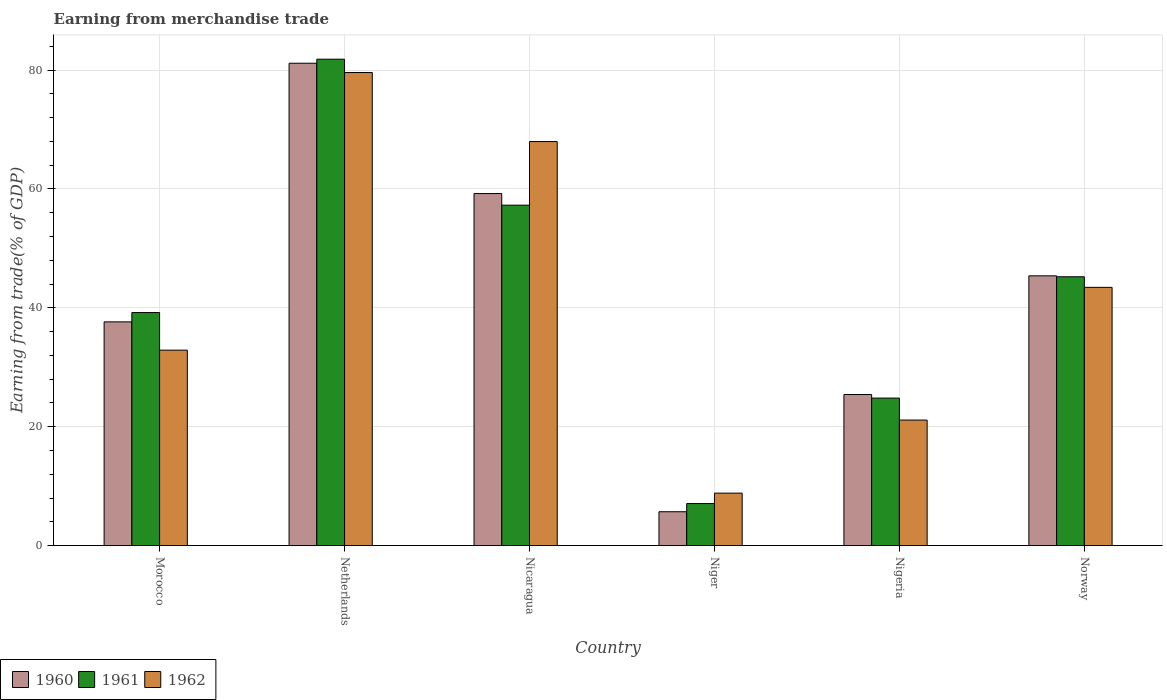How many different coloured bars are there?
Keep it short and to the point. 3. How many groups of bars are there?
Provide a succinct answer. 6. Are the number of bars per tick equal to the number of legend labels?
Provide a short and direct response. Yes. Are the number of bars on each tick of the X-axis equal?
Offer a very short reply. Yes. How many bars are there on the 2nd tick from the right?
Your response must be concise. 3. In how many cases, is the number of bars for a given country not equal to the number of legend labels?
Provide a succinct answer. 0. What is the earnings from trade in 1960 in Netherlands?
Offer a terse response. 81.16. Across all countries, what is the maximum earnings from trade in 1962?
Provide a short and direct response. 79.59. Across all countries, what is the minimum earnings from trade in 1960?
Your answer should be compact. 5.69. In which country was the earnings from trade in 1961 maximum?
Ensure brevity in your answer.  Netherlands. In which country was the earnings from trade in 1961 minimum?
Provide a succinct answer. Niger. What is the total earnings from trade in 1960 in the graph?
Keep it short and to the point. 254.51. What is the difference between the earnings from trade in 1960 in Netherlands and that in Nigeria?
Provide a short and direct response. 55.74. What is the difference between the earnings from trade in 1960 in Nicaragua and the earnings from trade in 1962 in Netherlands?
Your answer should be compact. -20.36. What is the average earnings from trade in 1961 per country?
Make the answer very short. 42.57. What is the difference between the earnings from trade of/in 1961 and earnings from trade of/in 1962 in Nigeria?
Offer a very short reply. 3.7. In how many countries, is the earnings from trade in 1962 greater than 28 %?
Keep it short and to the point. 4. What is the ratio of the earnings from trade in 1961 in Netherlands to that in Niger?
Keep it short and to the point. 11.58. What is the difference between the highest and the second highest earnings from trade in 1960?
Give a very brief answer. 21.93. What is the difference between the highest and the lowest earnings from trade in 1960?
Ensure brevity in your answer.  75.47. What does the 3rd bar from the left in Nicaragua represents?
Ensure brevity in your answer.  1962. Is it the case that in every country, the sum of the earnings from trade in 1961 and earnings from trade in 1962 is greater than the earnings from trade in 1960?
Provide a short and direct response. Yes. How many bars are there?
Your answer should be compact. 18. Are all the bars in the graph horizontal?
Your answer should be compact. No. How many countries are there in the graph?
Offer a terse response. 6. Are the values on the major ticks of Y-axis written in scientific E-notation?
Your response must be concise. No. Does the graph contain grids?
Your answer should be compact. Yes. What is the title of the graph?
Give a very brief answer. Earning from merchandise trade. Does "1971" appear as one of the legend labels in the graph?
Your answer should be very brief. No. What is the label or title of the Y-axis?
Ensure brevity in your answer.  Earning from trade(% of GDP). What is the Earning from trade(% of GDP) of 1960 in Morocco?
Offer a very short reply. 37.64. What is the Earning from trade(% of GDP) of 1961 in Morocco?
Ensure brevity in your answer.  39.21. What is the Earning from trade(% of GDP) in 1962 in Morocco?
Keep it short and to the point. 32.88. What is the Earning from trade(% of GDP) of 1960 in Netherlands?
Make the answer very short. 81.16. What is the Earning from trade(% of GDP) of 1961 in Netherlands?
Your answer should be compact. 81.83. What is the Earning from trade(% of GDP) in 1962 in Netherlands?
Your response must be concise. 79.59. What is the Earning from trade(% of GDP) in 1960 in Nicaragua?
Ensure brevity in your answer.  59.23. What is the Earning from trade(% of GDP) of 1961 in Nicaragua?
Offer a very short reply. 57.27. What is the Earning from trade(% of GDP) of 1962 in Nicaragua?
Provide a short and direct response. 67.98. What is the Earning from trade(% of GDP) of 1960 in Niger?
Your answer should be very brief. 5.69. What is the Earning from trade(% of GDP) of 1961 in Niger?
Your answer should be very brief. 7.07. What is the Earning from trade(% of GDP) in 1962 in Niger?
Ensure brevity in your answer.  8.82. What is the Earning from trade(% of GDP) in 1960 in Nigeria?
Make the answer very short. 25.41. What is the Earning from trade(% of GDP) of 1961 in Nigeria?
Provide a succinct answer. 24.81. What is the Earning from trade(% of GDP) in 1962 in Nigeria?
Your answer should be very brief. 21.12. What is the Earning from trade(% of GDP) in 1960 in Norway?
Give a very brief answer. 45.38. What is the Earning from trade(% of GDP) of 1961 in Norway?
Your response must be concise. 45.23. What is the Earning from trade(% of GDP) of 1962 in Norway?
Offer a terse response. 43.44. Across all countries, what is the maximum Earning from trade(% of GDP) in 1960?
Provide a succinct answer. 81.16. Across all countries, what is the maximum Earning from trade(% of GDP) of 1961?
Give a very brief answer. 81.83. Across all countries, what is the maximum Earning from trade(% of GDP) in 1962?
Offer a terse response. 79.59. Across all countries, what is the minimum Earning from trade(% of GDP) in 1960?
Ensure brevity in your answer.  5.69. Across all countries, what is the minimum Earning from trade(% of GDP) of 1961?
Your response must be concise. 7.07. Across all countries, what is the minimum Earning from trade(% of GDP) of 1962?
Your answer should be very brief. 8.82. What is the total Earning from trade(% of GDP) of 1960 in the graph?
Your response must be concise. 254.51. What is the total Earning from trade(% of GDP) in 1961 in the graph?
Provide a succinct answer. 255.42. What is the total Earning from trade(% of GDP) in 1962 in the graph?
Provide a succinct answer. 253.83. What is the difference between the Earning from trade(% of GDP) in 1960 in Morocco and that in Netherlands?
Your answer should be compact. -43.52. What is the difference between the Earning from trade(% of GDP) of 1961 in Morocco and that in Netherlands?
Your answer should be compact. -42.63. What is the difference between the Earning from trade(% of GDP) in 1962 in Morocco and that in Netherlands?
Your answer should be compact. -46.72. What is the difference between the Earning from trade(% of GDP) in 1960 in Morocco and that in Nicaragua?
Provide a short and direct response. -21.59. What is the difference between the Earning from trade(% of GDP) in 1961 in Morocco and that in Nicaragua?
Give a very brief answer. -18.07. What is the difference between the Earning from trade(% of GDP) of 1962 in Morocco and that in Nicaragua?
Ensure brevity in your answer.  -35.1. What is the difference between the Earning from trade(% of GDP) of 1960 in Morocco and that in Niger?
Your answer should be compact. 31.95. What is the difference between the Earning from trade(% of GDP) in 1961 in Morocco and that in Niger?
Your response must be concise. 32.14. What is the difference between the Earning from trade(% of GDP) in 1962 in Morocco and that in Niger?
Your answer should be very brief. 24.06. What is the difference between the Earning from trade(% of GDP) in 1960 in Morocco and that in Nigeria?
Provide a succinct answer. 12.22. What is the difference between the Earning from trade(% of GDP) in 1961 in Morocco and that in Nigeria?
Your answer should be compact. 14.39. What is the difference between the Earning from trade(% of GDP) in 1962 in Morocco and that in Nigeria?
Give a very brief answer. 11.76. What is the difference between the Earning from trade(% of GDP) of 1960 in Morocco and that in Norway?
Your answer should be very brief. -7.74. What is the difference between the Earning from trade(% of GDP) of 1961 in Morocco and that in Norway?
Provide a succinct answer. -6.02. What is the difference between the Earning from trade(% of GDP) of 1962 in Morocco and that in Norway?
Your answer should be very brief. -10.57. What is the difference between the Earning from trade(% of GDP) of 1960 in Netherlands and that in Nicaragua?
Give a very brief answer. 21.93. What is the difference between the Earning from trade(% of GDP) of 1961 in Netherlands and that in Nicaragua?
Your answer should be very brief. 24.56. What is the difference between the Earning from trade(% of GDP) of 1962 in Netherlands and that in Nicaragua?
Your answer should be very brief. 11.62. What is the difference between the Earning from trade(% of GDP) of 1960 in Netherlands and that in Niger?
Ensure brevity in your answer.  75.47. What is the difference between the Earning from trade(% of GDP) in 1961 in Netherlands and that in Niger?
Provide a short and direct response. 74.77. What is the difference between the Earning from trade(% of GDP) of 1962 in Netherlands and that in Niger?
Your response must be concise. 70.77. What is the difference between the Earning from trade(% of GDP) of 1960 in Netherlands and that in Nigeria?
Make the answer very short. 55.74. What is the difference between the Earning from trade(% of GDP) in 1961 in Netherlands and that in Nigeria?
Provide a succinct answer. 57.02. What is the difference between the Earning from trade(% of GDP) of 1962 in Netherlands and that in Nigeria?
Your answer should be very brief. 58.48. What is the difference between the Earning from trade(% of GDP) of 1960 in Netherlands and that in Norway?
Ensure brevity in your answer.  35.78. What is the difference between the Earning from trade(% of GDP) in 1961 in Netherlands and that in Norway?
Your answer should be compact. 36.61. What is the difference between the Earning from trade(% of GDP) of 1962 in Netherlands and that in Norway?
Give a very brief answer. 36.15. What is the difference between the Earning from trade(% of GDP) in 1960 in Nicaragua and that in Niger?
Your answer should be compact. 53.54. What is the difference between the Earning from trade(% of GDP) in 1961 in Nicaragua and that in Niger?
Your answer should be compact. 50.2. What is the difference between the Earning from trade(% of GDP) of 1962 in Nicaragua and that in Niger?
Offer a terse response. 59.16. What is the difference between the Earning from trade(% of GDP) in 1960 in Nicaragua and that in Nigeria?
Provide a short and direct response. 33.81. What is the difference between the Earning from trade(% of GDP) in 1961 in Nicaragua and that in Nigeria?
Provide a short and direct response. 32.46. What is the difference between the Earning from trade(% of GDP) of 1962 in Nicaragua and that in Nigeria?
Your answer should be very brief. 46.86. What is the difference between the Earning from trade(% of GDP) in 1960 in Nicaragua and that in Norway?
Your response must be concise. 13.85. What is the difference between the Earning from trade(% of GDP) in 1961 in Nicaragua and that in Norway?
Keep it short and to the point. 12.05. What is the difference between the Earning from trade(% of GDP) of 1962 in Nicaragua and that in Norway?
Make the answer very short. 24.53. What is the difference between the Earning from trade(% of GDP) of 1960 in Niger and that in Nigeria?
Your answer should be very brief. -19.72. What is the difference between the Earning from trade(% of GDP) in 1961 in Niger and that in Nigeria?
Provide a short and direct response. -17.75. What is the difference between the Earning from trade(% of GDP) of 1962 in Niger and that in Nigeria?
Make the answer very short. -12.3. What is the difference between the Earning from trade(% of GDP) in 1960 in Niger and that in Norway?
Make the answer very short. -39.69. What is the difference between the Earning from trade(% of GDP) in 1961 in Niger and that in Norway?
Keep it short and to the point. -38.16. What is the difference between the Earning from trade(% of GDP) in 1962 in Niger and that in Norway?
Provide a short and direct response. -34.62. What is the difference between the Earning from trade(% of GDP) in 1960 in Nigeria and that in Norway?
Make the answer very short. -19.97. What is the difference between the Earning from trade(% of GDP) of 1961 in Nigeria and that in Norway?
Keep it short and to the point. -20.41. What is the difference between the Earning from trade(% of GDP) in 1962 in Nigeria and that in Norway?
Provide a succinct answer. -22.33. What is the difference between the Earning from trade(% of GDP) of 1960 in Morocco and the Earning from trade(% of GDP) of 1961 in Netherlands?
Provide a short and direct response. -44.2. What is the difference between the Earning from trade(% of GDP) of 1960 in Morocco and the Earning from trade(% of GDP) of 1962 in Netherlands?
Keep it short and to the point. -41.96. What is the difference between the Earning from trade(% of GDP) in 1961 in Morocco and the Earning from trade(% of GDP) in 1962 in Netherlands?
Make the answer very short. -40.39. What is the difference between the Earning from trade(% of GDP) in 1960 in Morocco and the Earning from trade(% of GDP) in 1961 in Nicaragua?
Your answer should be compact. -19.64. What is the difference between the Earning from trade(% of GDP) of 1960 in Morocco and the Earning from trade(% of GDP) of 1962 in Nicaragua?
Provide a succinct answer. -30.34. What is the difference between the Earning from trade(% of GDP) of 1961 in Morocco and the Earning from trade(% of GDP) of 1962 in Nicaragua?
Ensure brevity in your answer.  -28.77. What is the difference between the Earning from trade(% of GDP) in 1960 in Morocco and the Earning from trade(% of GDP) in 1961 in Niger?
Ensure brevity in your answer.  30.57. What is the difference between the Earning from trade(% of GDP) of 1960 in Morocco and the Earning from trade(% of GDP) of 1962 in Niger?
Provide a short and direct response. 28.82. What is the difference between the Earning from trade(% of GDP) of 1961 in Morocco and the Earning from trade(% of GDP) of 1962 in Niger?
Ensure brevity in your answer.  30.38. What is the difference between the Earning from trade(% of GDP) of 1960 in Morocco and the Earning from trade(% of GDP) of 1961 in Nigeria?
Ensure brevity in your answer.  12.82. What is the difference between the Earning from trade(% of GDP) of 1960 in Morocco and the Earning from trade(% of GDP) of 1962 in Nigeria?
Offer a very short reply. 16.52. What is the difference between the Earning from trade(% of GDP) in 1961 in Morocco and the Earning from trade(% of GDP) in 1962 in Nigeria?
Ensure brevity in your answer.  18.09. What is the difference between the Earning from trade(% of GDP) of 1960 in Morocco and the Earning from trade(% of GDP) of 1961 in Norway?
Your answer should be very brief. -7.59. What is the difference between the Earning from trade(% of GDP) in 1960 in Morocco and the Earning from trade(% of GDP) in 1962 in Norway?
Your answer should be compact. -5.81. What is the difference between the Earning from trade(% of GDP) in 1961 in Morocco and the Earning from trade(% of GDP) in 1962 in Norway?
Provide a short and direct response. -4.24. What is the difference between the Earning from trade(% of GDP) of 1960 in Netherlands and the Earning from trade(% of GDP) of 1961 in Nicaragua?
Your answer should be compact. 23.88. What is the difference between the Earning from trade(% of GDP) of 1960 in Netherlands and the Earning from trade(% of GDP) of 1962 in Nicaragua?
Your answer should be very brief. 13.18. What is the difference between the Earning from trade(% of GDP) of 1961 in Netherlands and the Earning from trade(% of GDP) of 1962 in Nicaragua?
Make the answer very short. 13.86. What is the difference between the Earning from trade(% of GDP) of 1960 in Netherlands and the Earning from trade(% of GDP) of 1961 in Niger?
Your response must be concise. 74.09. What is the difference between the Earning from trade(% of GDP) of 1960 in Netherlands and the Earning from trade(% of GDP) of 1962 in Niger?
Make the answer very short. 72.34. What is the difference between the Earning from trade(% of GDP) in 1961 in Netherlands and the Earning from trade(% of GDP) in 1962 in Niger?
Ensure brevity in your answer.  73.01. What is the difference between the Earning from trade(% of GDP) in 1960 in Netherlands and the Earning from trade(% of GDP) in 1961 in Nigeria?
Make the answer very short. 56.34. What is the difference between the Earning from trade(% of GDP) of 1960 in Netherlands and the Earning from trade(% of GDP) of 1962 in Nigeria?
Make the answer very short. 60.04. What is the difference between the Earning from trade(% of GDP) in 1961 in Netherlands and the Earning from trade(% of GDP) in 1962 in Nigeria?
Provide a short and direct response. 60.72. What is the difference between the Earning from trade(% of GDP) of 1960 in Netherlands and the Earning from trade(% of GDP) of 1961 in Norway?
Ensure brevity in your answer.  35.93. What is the difference between the Earning from trade(% of GDP) in 1960 in Netherlands and the Earning from trade(% of GDP) in 1962 in Norway?
Offer a very short reply. 37.71. What is the difference between the Earning from trade(% of GDP) in 1961 in Netherlands and the Earning from trade(% of GDP) in 1962 in Norway?
Keep it short and to the point. 38.39. What is the difference between the Earning from trade(% of GDP) in 1960 in Nicaragua and the Earning from trade(% of GDP) in 1961 in Niger?
Ensure brevity in your answer.  52.16. What is the difference between the Earning from trade(% of GDP) in 1960 in Nicaragua and the Earning from trade(% of GDP) in 1962 in Niger?
Offer a terse response. 50.41. What is the difference between the Earning from trade(% of GDP) of 1961 in Nicaragua and the Earning from trade(% of GDP) of 1962 in Niger?
Your answer should be compact. 48.45. What is the difference between the Earning from trade(% of GDP) in 1960 in Nicaragua and the Earning from trade(% of GDP) in 1961 in Nigeria?
Keep it short and to the point. 34.41. What is the difference between the Earning from trade(% of GDP) of 1960 in Nicaragua and the Earning from trade(% of GDP) of 1962 in Nigeria?
Make the answer very short. 38.11. What is the difference between the Earning from trade(% of GDP) in 1961 in Nicaragua and the Earning from trade(% of GDP) in 1962 in Nigeria?
Your response must be concise. 36.16. What is the difference between the Earning from trade(% of GDP) of 1960 in Nicaragua and the Earning from trade(% of GDP) of 1961 in Norway?
Your answer should be very brief. 14. What is the difference between the Earning from trade(% of GDP) of 1960 in Nicaragua and the Earning from trade(% of GDP) of 1962 in Norway?
Your answer should be very brief. 15.78. What is the difference between the Earning from trade(% of GDP) in 1961 in Nicaragua and the Earning from trade(% of GDP) in 1962 in Norway?
Offer a terse response. 13.83. What is the difference between the Earning from trade(% of GDP) in 1960 in Niger and the Earning from trade(% of GDP) in 1961 in Nigeria?
Your response must be concise. -19.12. What is the difference between the Earning from trade(% of GDP) in 1960 in Niger and the Earning from trade(% of GDP) in 1962 in Nigeria?
Provide a succinct answer. -15.43. What is the difference between the Earning from trade(% of GDP) in 1961 in Niger and the Earning from trade(% of GDP) in 1962 in Nigeria?
Provide a short and direct response. -14.05. What is the difference between the Earning from trade(% of GDP) of 1960 in Niger and the Earning from trade(% of GDP) of 1961 in Norway?
Make the answer very short. -39.53. What is the difference between the Earning from trade(% of GDP) of 1960 in Niger and the Earning from trade(% of GDP) of 1962 in Norway?
Give a very brief answer. -37.75. What is the difference between the Earning from trade(% of GDP) in 1961 in Niger and the Earning from trade(% of GDP) in 1962 in Norway?
Make the answer very short. -36.38. What is the difference between the Earning from trade(% of GDP) of 1960 in Nigeria and the Earning from trade(% of GDP) of 1961 in Norway?
Your answer should be compact. -19.81. What is the difference between the Earning from trade(% of GDP) in 1960 in Nigeria and the Earning from trade(% of GDP) in 1962 in Norway?
Provide a short and direct response. -18.03. What is the difference between the Earning from trade(% of GDP) in 1961 in Nigeria and the Earning from trade(% of GDP) in 1962 in Norway?
Offer a very short reply. -18.63. What is the average Earning from trade(% of GDP) in 1960 per country?
Offer a very short reply. 42.42. What is the average Earning from trade(% of GDP) of 1961 per country?
Offer a terse response. 42.57. What is the average Earning from trade(% of GDP) of 1962 per country?
Provide a succinct answer. 42.3. What is the difference between the Earning from trade(% of GDP) in 1960 and Earning from trade(% of GDP) in 1961 in Morocco?
Make the answer very short. -1.57. What is the difference between the Earning from trade(% of GDP) of 1960 and Earning from trade(% of GDP) of 1962 in Morocco?
Your response must be concise. 4.76. What is the difference between the Earning from trade(% of GDP) in 1961 and Earning from trade(% of GDP) in 1962 in Morocco?
Provide a succinct answer. 6.33. What is the difference between the Earning from trade(% of GDP) in 1960 and Earning from trade(% of GDP) in 1961 in Netherlands?
Provide a succinct answer. -0.68. What is the difference between the Earning from trade(% of GDP) in 1960 and Earning from trade(% of GDP) in 1962 in Netherlands?
Your answer should be very brief. 1.56. What is the difference between the Earning from trade(% of GDP) in 1961 and Earning from trade(% of GDP) in 1962 in Netherlands?
Your answer should be very brief. 2.24. What is the difference between the Earning from trade(% of GDP) of 1960 and Earning from trade(% of GDP) of 1961 in Nicaragua?
Keep it short and to the point. 1.95. What is the difference between the Earning from trade(% of GDP) in 1960 and Earning from trade(% of GDP) in 1962 in Nicaragua?
Give a very brief answer. -8.75. What is the difference between the Earning from trade(% of GDP) of 1961 and Earning from trade(% of GDP) of 1962 in Nicaragua?
Provide a short and direct response. -10.7. What is the difference between the Earning from trade(% of GDP) in 1960 and Earning from trade(% of GDP) in 1961 in Niger?
Your answer should be compact. -1.38. What is the difference between the Earning from trade(% of GDP) in 1960 and Earning from trade(% of GDP) in 1962 in Niger?
Provide a succinct answer. -3.13. What is the difference between the Earning from trade(% of GDP) in 1961 and Earning from trade(% of GDP) in 1962 in Niger?
Your response must be concise. -1.75. What is the difference between the Earning from trade(% of GDP) of 1960 and Earning from trade(% of GDP) of 1961 in Nigeria?
Provide a succinct answer. 0.6. What is the difference between the Earning from trade(% of GDP) of 1960 and Earning from trade(% of GDP) of 1962 in Nigeria?
Provide a short and direct response. 4.3. What is the difference between the Earning from trade(% of GDP) in 1961 and Earning from trade(% of GDP) in 1962 in Nigeria?
Ensure brevity in your answer.  3.7. What is the difference between the Earning from trade(% of GDP) of 1960 and Earning from trade(% of GDP) of 1961 in Norway?
Make the answer very short. 0.16. What is the difference between the Earning from trade(% of GDP) of 1960 and Earning from trade(% of GDP) of 1962 in Norway?
Provide a short and direct response. 1.94. What is the difference between the Earning from trade(% of GDP) of 1961 and Earning from trade(% of GDP) of 1962 in Norway?
Your answer should be very brief. 1.78. What is the ratio of the Earning from trade(% of GDP) in 1960 in Morocco to that in Netherlands?
Provide a succinct answer. 0.46. What is the ratio of the Earning from trade(% of GDP) in 1961 in Morocco to that in Netherlands?
Make the answer very short. 0.48. What is the ratio of the Earning from trade(% of GDP) of 1962 in Morocco to that in Netherlands?
Give a very brief answer. 0.41. What is the ratio of the Earning from trade(% of GDP) in 1960 in Morocco to that in Nicaragua?
Provide a succinct answer. 0.64. What is the ratio of the Earning from trade(% of GDP) of 1961 in Morocco to that in Nicaragua?
Provide a succinct answer. 0.68. What is the ratio of the Earning from trade(% of GDP) in 1962 in Morocco to that in Nicaragua?
Offer a terse response. 0.48. What is the ratio of the Earning from trade(% of GDP) in 1960 in Morocco to that in Niger?
Provide a short and direct response. 6.61. What is the ratio of the Earning from trade(% of GDP) of 1961 in Morocco to that in Niger?
Make the answer very short. 5.55. What is the ratio of the Earning from trade(% of GDP) of 1962 in Morocco to that in Niger?
Ensure brevity in your answer.  3.73. What is the ratio of the Earning from trade(% of GDP) of 1960 in Morocco to that in Nigeria?
Give a very brief answer. 1.48. What is the ratio of the Earning from trade(% of GDP) of 1961 in Morocco to that in Nigeria?
Keep it short and to the point. 1.58. What is the ratio of the Earning from trade(% of GDP) of 1962 in Morocco to that in Nigeria?
Offer a terse response. 1.56. What is the ratio of the Earning from trade(% of GDP) of 1960 in Morocco to that in Norway?
Provide a succinct answer. 0.83. What is the ratio of the Earning from trade(% of GDP) in 1961 in Morocco to that in Norway?
Give a very brief answer. 0.87. What is the ratio of the Earning from trade(% of GDP) of 1962 in Morocco to that in Norway?
Offer a very short reply. 0.76. What is the ratio of the Earning from trade(% of GDP) of 1960 in Netherlands to that in Nicaragua?
Your answer should be very brief. 1.37. What is the ratio of the Earning from trade(% of GDP) of 1961 in Netherlands to that in Nicaragua?
Provide a succinct answer. 1.43. What is the ratio of the Earning from trade(% of GDP) of 1962 in Netherlands to that in Nicaragua?
Provide a succinct answer. 1.17. What is the ratio of the Earning from trade(% of GDP) in 1960 in Netherlands to that in Niger?
Provide a succinct answer. 14.26. What is the ratio of the Earning from trade(% of GDP) in 1961 in Netherlands to that in Niger?
Provide a short and direct response. 11.58. What is the ratio of the Earning from trade(% of GDP) in 1962 in Netherlands to that in Niger?
Provide a succinct answer. 9.02. What is the ratio of the Earning from trade(% of GDP) of 1960 in Netherlands to that in Nigeria?
Your answer should be very brief. 3.19. What is the ratio of the Earning from trade(% of GDP) in 1961 in Netherlands to that in Nigeria?
Offer a very short reply. 3.3. What is the ratio of the Earning from trade(% of GDP) of 1962 in Netherlands to that in Nigeria?
Offer a very short reply. 3.77. What is the ratio of the Earning from trade(% of GDP) in 1960 in Netherlands to that in Norway?
Offer a terse response. 1.79. What is the ratio of the Earning from trade(% of GDP) in 1961 in Netherlands to that in Norway?
Make the answer very short. 1.81. What is the ratio of the Earning from trade(% of GDP) in 1962 in Netherlands to that in Norway?
Provide a short and direct response. 1.83. What is the ratio of the Earning from trade(% of GDP) of 1960 in Nicaragua to that in Niger?
Your answer should be very brief. 10.41. What is the ratio of the Earning from trade(% of GDP) in 1961 in Nicaragua to that in Niger?
Your answer should be compact. 8.1. What is the ratio of the Earning from trade(% of GDP) in 1962 in Nicaragua to that in Niger?
Give a very brief answer. 7.71. What is the ratio of the Earning from trade(% of GDP) of 1960 in Nicaragua to that in Nigeria?
Offer a very short reply. 2.33. What is the ratio of the Earning from trade(% of GDP) in 1961 in Nicaragua to that in Nigeria?
Offer a terse response. 2.31. What is the ratio of the Earning from trade(% of GDP) in 1962 in Nicaragua to that in Nigeria?
Your response must be concise. 3.22. What is the ratio of the Earning from trade(% of GDP) in 1960 in Nicaragua to that in Norway?
Ensure brevity in your answer.  1.31. What is the ratio of the Earning from trade(% of GDP) of 1961 in Nicaragua to that in Norway?
Offer a very short reply. 1.27. What is the ratio of the Earning from trade(% of GDP) of 1962 in Nicaragua to that in Norway?
Provide a short and direct response. 1.56. What is the ratio of the Earning from trade(% of GDP) of 1960 in Niger to that in Nigeria?
Offer a terse response. 0.22. What is the ratio of the Earning from trade(% of GDP) of 1961 in Niger to that in Nigeria?
Ensure brevity in your answer.  0.28. What is the ratio of the Earning from trade(% of GDP) of 1962 in Niger to that in Nigeria?
Provide a short and direct response. 0.42. What is the ratio of the Earning from trade(% of GDP) of 1960 in Niger to that in Norway?
Your answer should be very brief. 0.13. What is the ratio of the Earning from trade(% of GDP) of 1961 in Niger to that in Norway?
Provide a succinct answer. 0.16. What is the ratio of the Earning from trade(% of GDP) in 1962 in Niger to that in Norway?
Offer a terse response. 0.2. What is the ratio of the Earning from trade(% of GDP) of 1960 in Nigeria to that in Norway?
Provide a succinct answer. 0.56. What is the ratio of the Earning from trade(% of GDP) in 1961 in Nigeria to that in Norway?
Your answer should be compact. 0.55. What is the ratio of the Earning from trade(% of GDP) in 1962 in Nigeria to that in Norway?
Give a very brief answer. 0.49. What is the difference between the highest and the second highest Earning from trade(% of GDP) of 1960?
Make the answer very short. 21.93. What is the difference between the highest and the second highest Earning from trade(% of GDP) in 1961?
Provide a succinct answer. 24.56. What is the difference between the highest and the second highest Earning from trade(% of GDP) in 1962?
Provide a succinct answer. 11.62. What is the difference between the highest and the lowest Earning from trade(% of GDP) of 1960?
Provide a succinct answer. 75.47. What is the difference between the highest and the lowest Earning from trade(% of GDP) in 1961?
Ensure brevity in your answer.  74.77. What is the difference between the highest and the lowest Earning from trade(% of GDP) of 1962?
Your answer should be compact. 70.77. 